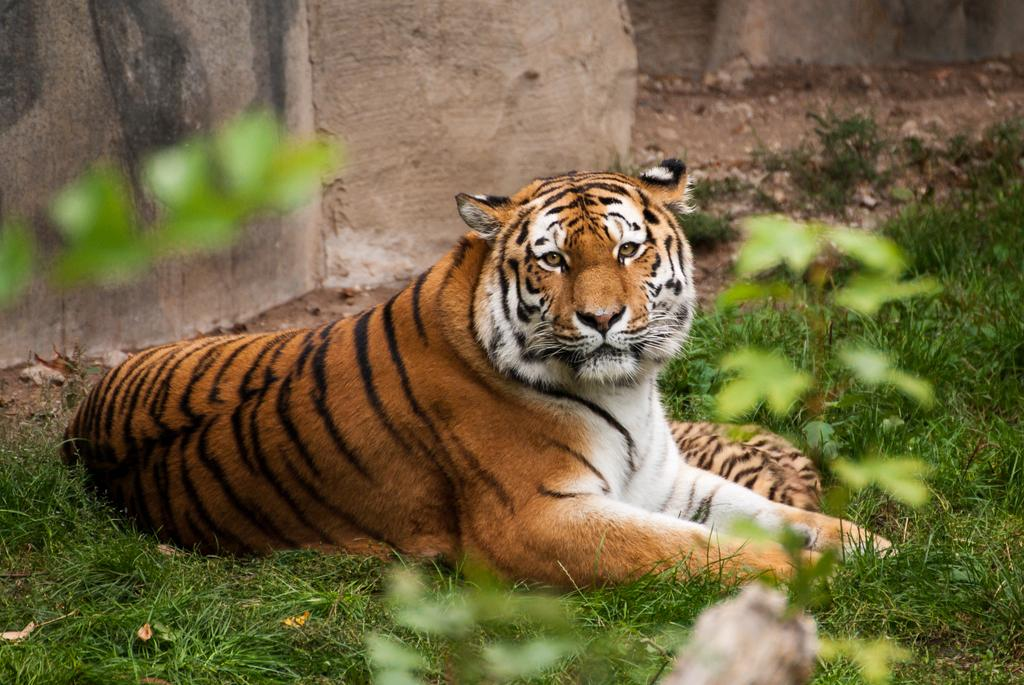What type of animal is in the image? There is a tiger in the image. Where is the tiger located? The tiger is on the grass. What other natural elements can be seen in the image? There are plants visible in the image. What type of man-made structure is present in the image? There is a wall in the image. What type of maid can be seen cleaning the tiger's enclosure in the image? There is no maid present in the image; it only features a tiger on the grass, plants, and a wall. 